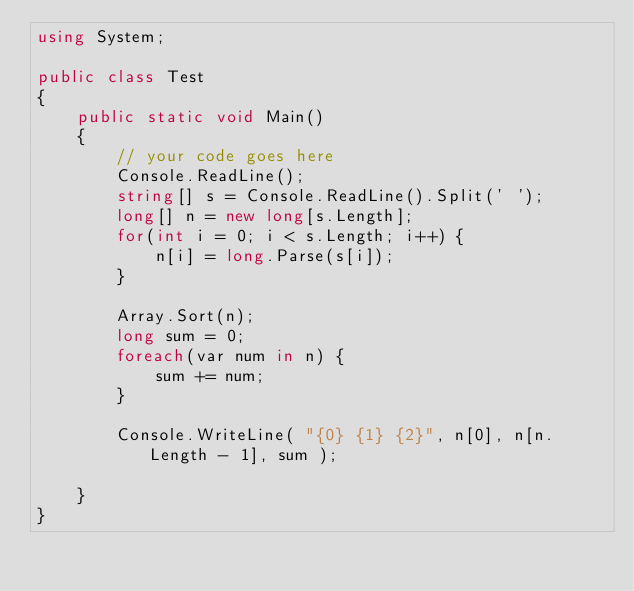Convert code to text. <code><loc_0><loc_0><loc_500><loc_500><_C#_>using System;

public class Test
{
	public static void Main()
	{
		// your code goes here
		Console.ReadLine();
		string[] s = Console.ReadLine().Split(' ');
		long[] n = new long[s.Length];
		for(int i = 0; i < s.Length; i++) {
			n[i] = long.Parse(s[i]);
		}
		
		Array.Sort(n);
		long sum = 0;
		foreach(var num in n) {
			sum += num;
		}
		
		Console.WriteLine( "{0} {1} {2}", n[0], n[n.Length - 1], sum );
		
	}
}</code> 